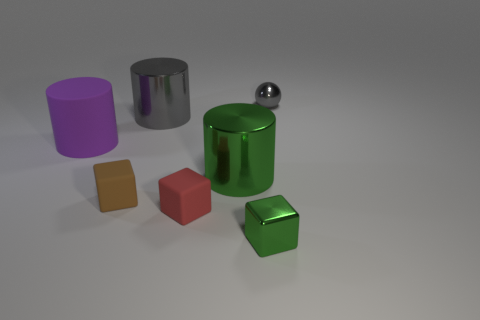Is there any other thing that has the same shape as the tiny gray shiny thing?
Offer a terse response. No. What size is the purple object that is made of the same material as the brown block?
Your answer should be very brief. Large. Is the number of things that are in front of the small gray sphere greater than the number of tiny balls that are in front of the red object?
Give a very brief answer. Yes. Is there another tiny object of the same shape as the small red object?
Keep it short and to the point. Yes. Is the size of the metal cylinder in front of the purple thing the same as the small red cube?
Your response must be concise. No. Is there a blue metal object?
Offer a very short reply. No. What number of things are either blocks that are right of the tiny brown matte block or small brown rubber blocks?
Provide a short and direct response. 3. Is the color of the tiny sphere the same as the large shiny object that is behind the big purple matte thing?
Your answer should be compact. Yes. Are there any cylinders of the same size as the brown matte block?
Your response must be concise. No. There is a small object right of the tiny block that is to the right of the green cylinder; what is it made of?
Ensure brevity in your answer.  Metal. 